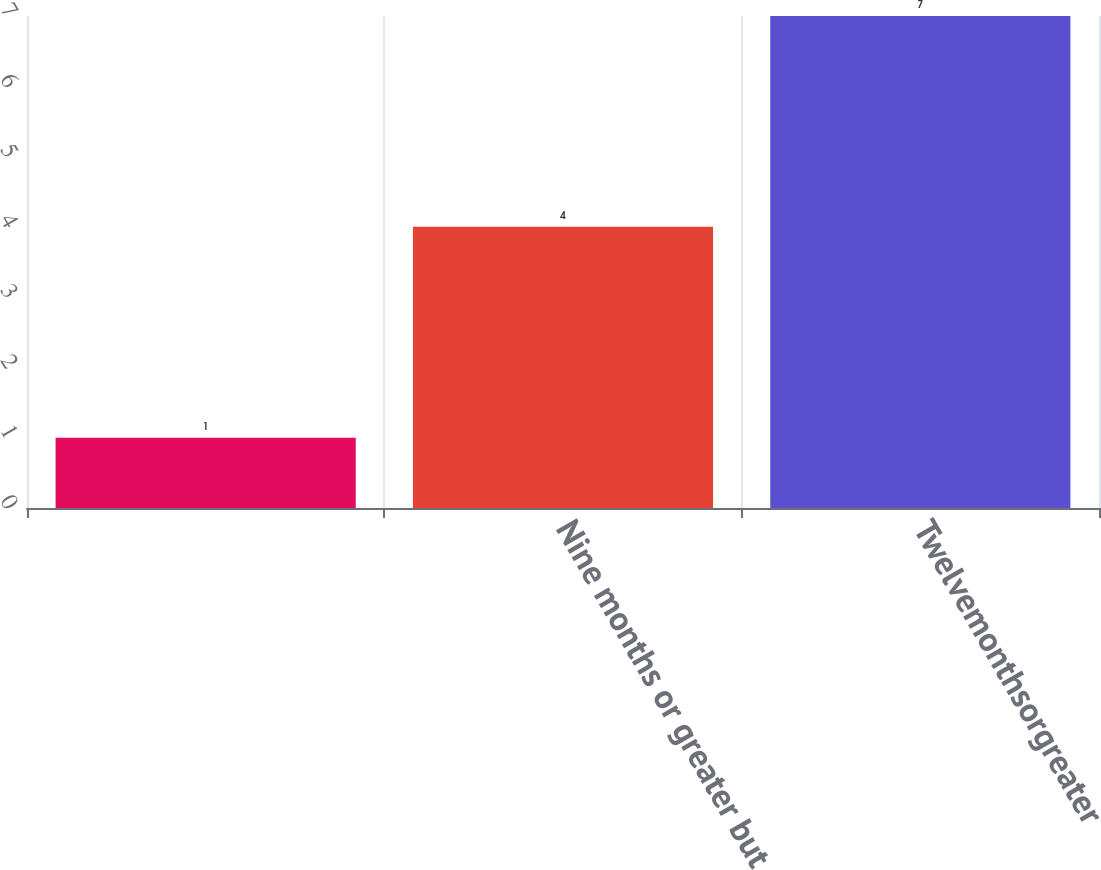Convert chart. <chart><loc_0><loc_0><loc_500><loc_500><bar_chart><ecel><fcel>Nine months or greater but<fcel>Twelvemonthsorgreater<nl><fcel>1<fcel>4<fcel>7<nl></chart> 